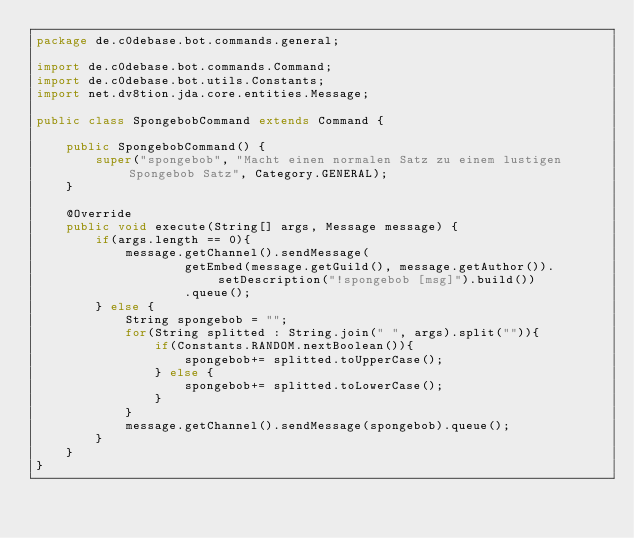Convert code to text. <code><loc_0><loc_0><loc_500><loc_500><_Java_>package de.c0debase.bot.commands.general;

import de.c0debase.bot.commands.Command;
import de.c0debase.bot.utils.Constants;
import net.dv8tion.jda.core.entities.Message;

public class SpongebobCommand extends Command {

    public SpongebobCommand() {
        super("spongebob", "Macht einen normalen Satz zu einem lustigen Spongebob Satz", Category.GENERAL);
    }

    @Override
    public void execute(String[] args, Message message) {
        if(args.length == 0){
            message.getChannel().sendMessage(
                    getEmbed(message.getGuild(), message.getAuthor()).setDescription("!spongebob [msg]").build())
                    .queue();
        } else {
            String spongebob = "";
            for(String splitted : String.join(" ", args).split("")){
                if(Constants.RANDOM.nextBoolean()){
                    spongebob+= splitted.toUpperCase();
                } else {
                    spongebob+= splitted.toLowerCase();
                }
            }
            message.getChannel().sendMessage(spongebob).queue();
        }
    }
}
</code> 